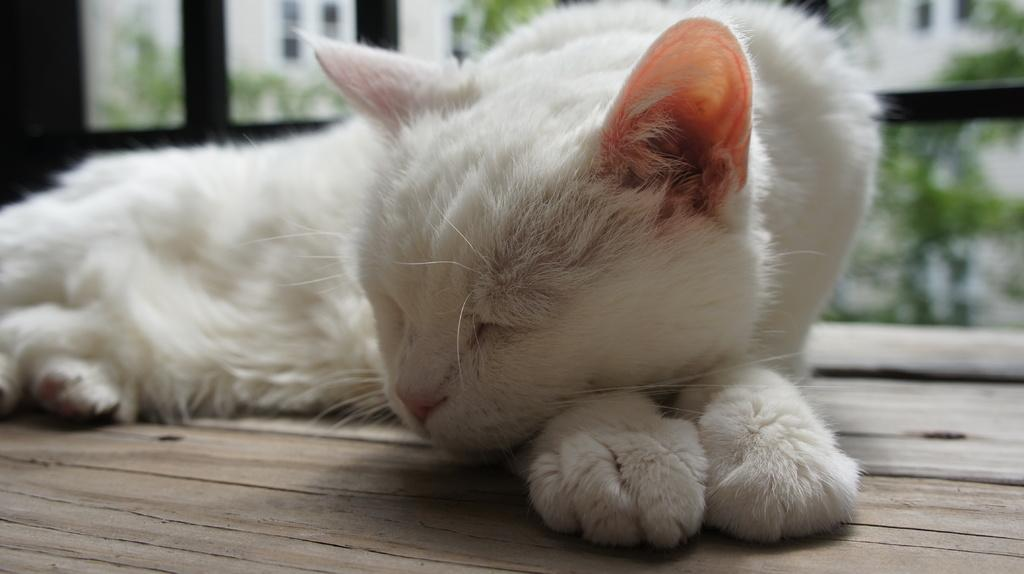What type of animal is in the image? There is a cat in the image. What can be seen in the background of the image? There are glass windows and an object in the background of the image. What is the surface at the bottom of the image made of? The surface at the bottom of the image is made of wood. What type of wrench is being used to adjust the cat's position in the image? There is no wrench or adjustment being made to the cat's position in the image; the cat is simply sitting on the wooden surface. Is there a rainstorm occurring in the image? There is no indication of a rainstorm in the image; the glass windows suggest a clear view of the background. 